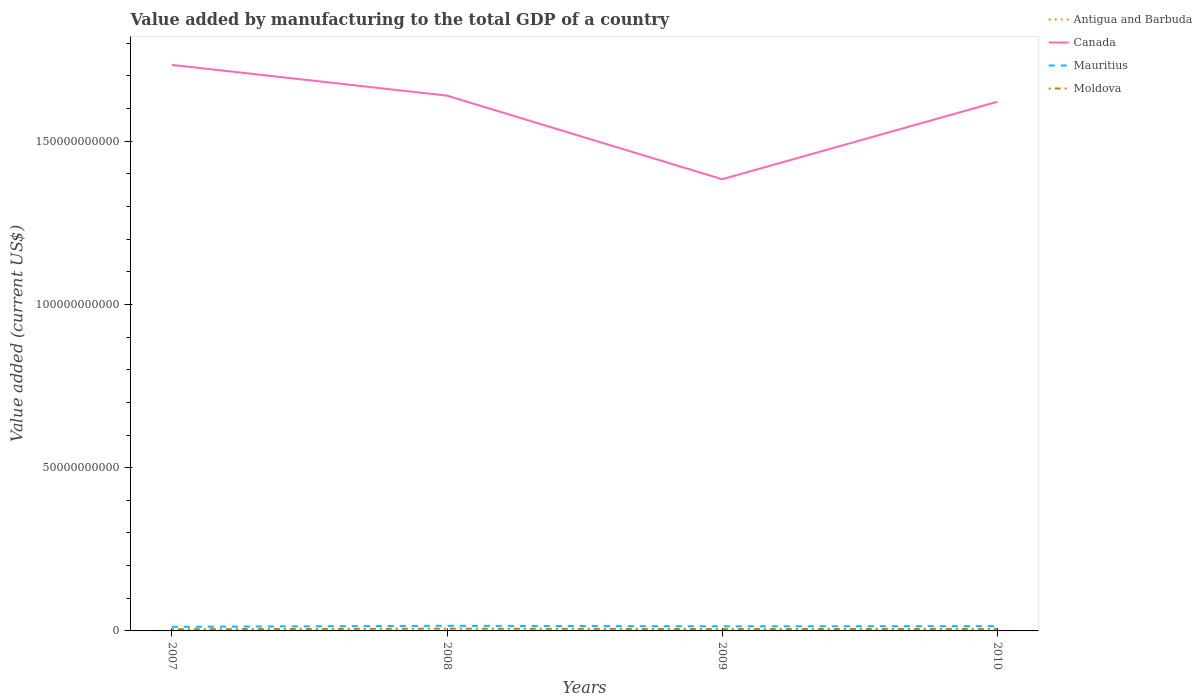Across all years, what is the maximum value added by manufacturing to the total GDP in Canada?
Offer a terse response. 1.38e+11. In which year was the value added by manufacturing to the total GDP in Canada maximum?
Keep it short and to the point. 2009. What is the total value added by manufacturing to the total GDP in Moldova in the graph?
Provide a short and direct response. -1.64e+08. What is the difference between the highest and the second highest value added by manufacturing to the total GDP in Moldova?
Offer a terse response. 1.64e+08. What is the difference between the highest and the lowest value added by manufacturing to the total GDP in Moldova?
Give a very brief answer. 2. How many lines are there?
Your response must be concise. 4. What is the difference between two consecutive major ticks on the Y-axis?
Provide a succinct answer. 5.00e+1. Does the graph contain any zero values?
Make the answer very short. No. Where does the legend appear in the graph?
Provide a short and direct response. Top right. What is the title of the graph?
Make the answer very short. Value added by manufacturing to the total GDP of a country. Does "Antigua and Barbuda" appear as one of the legend labels in the graph?
Your answer should be very brief. Yes. What is the label or title of the X-axis?
Your answer should be compact. Years. What is the label or title of the Y-axis?
Ensure brevity in your answer.  Value added (current US$). What is the Value added (current US$) of Antigua and Barbuda in 2007?
Give a very brief answer. 2.22e+07. What is the Value added (current US$) of Canada in 2007?
Your answer should be compact. 1.73e+11. What is the Value added (current US$) of Mauritius in 2007?
Offer a terse response. 1.26e+09. What is the Value added (current US$) in Moldova in 2007?
Make the answer very short. 5.19e+08. What is the Value added (current US$) of Antigua and Barbuda in 2008?
Provide a succinct answer. 2.18e+07. What is the Value added (current US$) of Canada in 2008?
Keep it short and to the point. 1.64e+11. What is the Value added (current US$) in Mauritius in 2008?
Your response must be concise. 1.58e+09. What is the Value added (current US$) of Moldova in 2008?
Offer a very short reply. 6.83e+08. What is the Value added (current US$) in Antigua and Barbuda in 2009?
Offer a terse response. 2.53e+07. What is the Value added (current US$) of Canada in 2009?
Provide a succinct answer. 1.38e+11. What is the Value added (current US$) of Mauritius in 2009?
Ensure brevity in your answer.  1.41e+09. What is the Value added (current US$) of Moldova in 2009?
Ensure brevity in your answer.  5.75e+08. What is the Value added (current US$) in Antigua and Barbuda in 2010?
Keep it short and to the point. 2.48e+07. What is the Value added (current US$) of Canada in 2010?
Offer a terse response. 1.62e+11. What is the Value added (current US$) in Mauritius in 2010?
Your answer should be very brief. 1.47e+09. What is the Value added (current US$) in Moldova in 2010?
Your answer should be very brief. 6.16e+08. Across all years, what is the maximum Value added (current US$) in Antigua and Barbuda?
Your response must be concise. 2.53e+07. Across all years, what is the maximum Value added (current US$) of Canada?
Offer a very short reply. 1.73e+11. Across all years, what is the maximum Value added (current US$) of Mauritius?
Offer a terse response. 1.58e+09. Across all years, what is the maximum Value added (current US$) of Moldova?
Your answer should be very brief. 6.83e+08. Across all years, what is the minimum Value added (current US$) of Antigua and Barbuda?
Offer a terse response. 2.18e+07. Across all years, what is the minimum Value added (current US$) in Canada?
Offer a terse response. 1.38e+11. Across all years, what is the minimum Value added (current US$) in Mauritius?
Ensure brevity in your answer.  1.26e+09. Across all years, what is the minimum Value added (current US$) in Moldova?
Ensure brevity in your answer.  5.19e+08. What is the total Value added (current US$) of Antigua and Barbuda in the graph?
Give a very brief answer. 9.41e+07. What is the total Value added (current US$) in Canada in the graph?
Provide a succinct answer. 6.38e+11. What is the total Value added (current US$) in Mauritius in the graph?
Make the answer very short. 5.71e+09. What is the total Value added (current US$) in Moldova in the graph?
Provide a short and direct response. 2.39e+09. What is the difference between the Value added (current US$) of Antigua and Barbuda in 2007 and that in 2008?
Provide a short and direct response. 4.83e+05. What is the difference between the Value added (current US$) of Canada in 2007 and that in 2008?
Ensure brevity in your answer.  9.42e+09. What is the difference between the Value added (current US$) in Mauritius in 2007 and that in 2008?
Ensure brevity in your answer.  -3.15e+08. What is the difference between the Value added (current US$) of Moldova in 2007 and that in 2008?
Your answer should be very brief. -1.64e+08. What is the difference between the Value added (current US$) of Antigua and Barbuda in 2007 and that in 2009?
Offer a terse response. -3.07e+06. What is the difference between the Value added (current US$) of Canada in 2007 and that in 2009?
Offer a very short reply. 3.50e+1. What is the difference between the Value added (current US$) of Mauritius in 2007 and that in 2009?
Provide a short and direct response. -1.45e+08. What is the difference between the Value added (current US$) of Moldova in 2007 and that in 2009?
Ensure brevity in your answer.  -5.63e+07. What is the difference between the Value added (current US$) in Antigua and Barbuda in 2007 and that in 2010?
Offer a terse response. -2.53e+06. What is the difference between the Value added (current US$) in Canada in 2007 and that in 2010?
Give a very brief answer. 1.13e+1. What is the difference between the Value added (current US$) in Mauritius in 2007 and that in 2010?
Provide a short and direct response. -2.07e+08. What is the difference between the Value added (current US$) of Moldova in 2007 and that in 2010?
Your answer should be very brief. -9.70e+07. What is the difference between the Value added (current US$) in Antigua and Barbuda in 2008 and that in 2009?
Ensure brevity in your answer.  -3.56e+06. What is the difference between the Value added (current US$) of Canada in 2008 and that in 2009?
Your answer should be very brief. 2.56e+1. What is the difference between the Value added (current US$) in Mauritius in 2008 and that in 2009?
Your response must be concise. 1.70e+08. What is the difference between the Value added (current US$) of Moldova in 2008 and that in 2009?
Your answer should be very brief. 1.07e+08. What is the difference between the Value added (current US$) of Antigua and Barbuda in 2008 and that in 2010?
Ensure brevity in your answer.  -3.01e+06. What is the difference between the Value added (current US$) in Canada in 2008 and that in 2010?
Provide a succinct answer. 1.87e+09. What is the difference between the Value added (current US$) in Mauritius in 2008 and that in 2010?
Provide a succinct answer. 1.08e+08. What is the difference between the Value added (current US$) of Moldova in 2008 and that in 2010?
Provide a short and direct response. 6.67e+07. What is the difference between the Value added (current US$) of Antigua and Barbuda in 2009 and that in 2010?
Give a very brief answer. 5.49e+05. What is the difference between the Value added (current US$) of Canada in 2009 and that in 2010?
Provide a succinct answer. -2.37e+1. What is the difference between the Value added (current US$) of Mauritius in 2009 and that in 2010?
Keep it short and to the point. -6.25e+07. What is the difference between the Value added (current US$) in Moldova in 2009 and that in 2010?
Your answer should be very brief. -4.07e+07. What is the difference between the Value added (current US$) in Antigua and Barbuda in 2007 and the Value added (current US$) in Canada in 2008?
Your answer should be compact. -1.64e+11. What is the difference between the Value added (current US$) of Antigua and Barbuda in 2007 and the Value added (current US$) of Mauritius in 2008?
Your answer should be very brief. -1.55e+09. What is the difference between the Value added (current US$) in Antigua and Barbuda in 2007 and the Value added (current US$) in Moldova in 2008?
Offer a very short reply. -6.60e+08. What is the difference between the Value added (current US$) of Canada in 2007 and the Value added (current US$) of Mauritius in 2008?
Make the answer very short. 1.72e+11. What is the difference between the Value added (current US$) in Canada in 2007 and the Value added (current US$) in Moldova in 2008?
Make the answer very short. 1.73e+11. What is the difference between the Value added (current US$) of Mauritius in 2007 and the Value added (current US$) of Moldova in 2008?
Provide a short and direct response. 5.78e+08. What is the difference between the Value added (current US$) in Antigua and Barbuda in 2007 and the Value added (current US$) in Canada in 2009?
Give a very brief answer. -1.38e+11. What is the difference between the Value added (current US$) in Antigua and Barbuda in 2007 and the Value added (current US$) in Mauritius in 2009?
Your response must be concise. -1.38e+09. What is the difference between the Value added (current US$) in Antigua and Barbuda in 2007 and the Value added (current US$) in Moldova in 2009?
Your answer should be compact. -5.53e+08. What is the difference between the Value added (current US$) in Canada in 2007 and the Value added (current US$) in Mauritius in 2009?
Your answer should be very brief. 1.72e+11. What is the difference between the Value added (current US$) of Canada in 2007 and the Value added (current US$) of Moldova in 2009?
Provide a short and direct response. 1.73e+11. What is the difference between the Value added (current US$) in Mauritius in 2007 and the Value added (current US$) in Moldova in 2009?
Make the answer very short. 6.85e+08. What is the difference between the Value added (current US$) of Antigua and Barbuda in 2007 and the Value added (current US$) of Canada in 2010?
Provide a succinct answer. -1.62e+11. What is the difference between the Value added (current US$) in Antigua and Barbuda in 2007 and the Value added (current US$) in Mauritius in 2010?
Your response must be concise. -1.45e+09. What is the difference between the Value added (current US$) of Antigua and Barbuda in 2007 and the Value added (current US$) of Moldova in 2010?
Ensure brevity in your answer.  -5.94e+08. What is the difference between the Value added (current US$) in Canada in 2007 and the Value added (current US$) in Mauritius in 2010?
Your answer should be very brief. 1.72e+11. What is the difference between the Value added (current US$) in Canada in 2007 and the Value added (current US$) in Moldova in 2010?
Provide a succinct answer. 1.73e+11. What is the difference between the Value added (current US$) in Mauritius in 2007 and the Value added (current US$) in Moldova in 2010?
Your response must be concise. 6.44e+08. What is the difference between the Value added (current US$) of Antigua and Barbuda in 2008 and the Value added (current US$) of Canada in 2009?
Offer a terse response. -1.38e+11. What is the difference between the Value added (current US$) of Antigua and Barbuda in 2008 and the Value added (current US$) of Mauritius in 2009?
Your response must be concise. -1.38e+09. What is the difference between the Value added (current US$) of Antigua and Barbuda in 2008 and the Value added (current US$) of Moldova in 2009?
Provide a short and direct response. -5.53e+08. What is the difference between the Value added (current US$) of Canada in 2008 and the Value added (current US$) of Mauritius in 2009?
Offer a terse response. 1.63e+11. What is the difference between the Value added (current US$) of Canada in 2008 and the Value added (current US$) of Moldova in 2009?
Your answer should be very brief. 1.63e+11. What is the difference between the Value added (current US$) of Mauritius in 2008 and the Value added (current US$) of Moldova in 2009?
Offer a very short reply. 1.00e+09. What is the difference between the Value added (current US$) of Antigua and Barbuda in 2008 and the Value added (current US$) of Canada in 2010?
Give a very brief answer. -1.62e+11. What is the difference between the Value added (current US$) in Antigua and Barbuda in 2008 and the Value added (current US$) in Mauritius in 2010?
Ensure brevity in your answer.  -1.45e+09. What is the difference between the Value added (current US$) of Antigua and Barbuda in 2008 and the Value added (current US$) of Moldova in 2010?
Your answer should be compact. -5.94e+08. What is the difference between the Value added (current US$) of Canada in 2008 and the Value added (current US$) of Mauritius in 2010?
Offer a terse response. 1.62e+11. What is the difference between the Value added (current US$) in Canada in 2008 and the Value added (current US$) in Moldova in 2010?
Ensure brevity in your answer.  1.63e+11. What is the difference between the Value added (current US$) of Mauritius in 2008 and the Value added (current US$) of Moldova in 2010?
Make the answer very short. 9.59e+08. What is the difference between the Value added (current US$) in Antigua and Barbuda in 2009 and the Value added (current US$) in Canada in 2010?
Ensure brevity in your answer.  -1.62e+11. What is the difference between the Value added (current US$) in Antigua and Barbuda in 2009 and the Value added (current US$) in Mauritius in 2010?
Make the answer very short. -1.44e+09. What is the difference between the Value added (current US$) of Antigua and Barbuda in 2009 and the Value added (current US$) of Moldova in 2010?
Ensure brevity in your answer.  -5.91e+08. What is the difference between the Value added (current US$) of Canada in 2009 and the Value added (current US$) of Mauritius in 2010?
Your answer should be very brief. 1.37e+11. What is the difference between the Value added (current US$) of Canada in 2009 and the Value added (current US$) of Moldova in 2010?
Offer a very short reply. 1.38e+11. What is the difference between the Value added (current US$) in Mauritius in 2009 and the Value added (current US$) in Moldova in 2010?
Your response must be concise. 7.89e+08. What is the average Value added (current US$) in Antigua and Barbuda per year?
Offer a terse response. 2.35e+07. What is the average Value added (current US$) of Canada per year?
Your response must be concise. 1.59e+11. What is the average Value added (current US$) of Mauritius per year?
Offer a terse response. 1.43e+09. What is the average Value added (current US$) of Moldova per year?
Provide a short and direct response. 5.98e+08. In the year 2007, what is the difference between the Value added (current US$) in Antigua and Barbuda and Value added (current US$) in Canada?
Make the answer very short. -1.73e+11. In the year 2007, what is the difference between the Value added (current US$) in Antigua and Barbuda and Value added (current US$) in Mauritius?
Provide a short and direct response. -1.24e+09. In the year 2007, what is the difference between the Value added (current US$) in Antigua and Barbuda and Value added (current US$) in Moldova?
Your response must be concise. -4.97e+08. In the year 2007, what is the difference between the Value added (current US$) of Canada and Value added (current US$) of Mauritius?
Keep it short and to the point. 1.72e+11. In the year 2007, what is the difference between the Value added (current US$) of Canada and Value added (current US$) of Moldova?
Provide a succinct answer. 1.73e+11. In the year 2007, what is the difference between the Value added (current US$) in Mauritius and Value added (current US$) in Moldova?
Provide a succinct answer. 7.41e+08. In the year 2008, what is the difference between the Value added (current US$) of Antigua and Barbuda and Value added (current US$) of Canada?
Offer a very short reply. -1.64e+11. In the year 2008, what is the difference between the Value added (current US$) in Antigua and Barbuda and Value added (current US$) in Mauritius?
Offer a very short reply. -1.55e+09. In the year 2008, what is the difference between the Value added (current US$) in Antigua and Barbuda and Value added (current US$) in Moldova?
Keep it short and to the point. -6.61e+08. In the year 2008, what is the difference between the Value added (current US$) of Canada and Value added (current US$) of Mauritius?
Your answer should be compact. 1.62e+11. In the year 2008, what is the difference between the Value added (current US$) in Canada and Value added (current US$) in Moldova?
Provide a short and direct response. 1.63e+11. In the year 2008, what is the difference between the Value added (current US$) in Mauritius and Value added (current US$) in Moldova?
Provide a succinct answer. 8.92e+08. In the year 2009, what is the difference between the Value added (current US$) in Antigua and Barbuda and Value added (current US$) in Canada?
Keep it short and to the point. -1.38e+11. In the year 2009, what is the difference between the Value added (current US$) of Antigua and Barbuda and Value added (current US$) of Mauritius?
Give a very brief answer. -1.38e+09. In the year 2009, what is the difference between the Value added (current US$) of Antigua and Barbuda and Value added (current US$) of Moldova?
Offer a terse response. -5.50e+08. In the year 2009, what is the difference between the Value added (current US$) in Canada and Value added (current US$) in Mauritius?
Provide a succinct answer. 1.37e+11. In the year 2009, what is the difference between the Value added (current US$) of Canada and Value added (current US$) of Moldova?
Provide a short and direct response. 1.38e+11. In the year 2009, what is the difference between the Value added (current US$) in Mauritius and Value added (current US$) in Moldova?
Give a very brief answer. 8.30e+08. In the year 2010, what is the difference between the Value added (current US$) in Antigua and Barbuda and Value added (current US$) in Canada?
Offer a terse response. -1.62e+11. In the year 2010, what is the difference between the Value added (current US$) of Antigua and Barbuda and Value added (current US$) of Mauritius?
Make the answer very short. -1.44e+09. In the year 2010, what is the difference between the Value added (current US$) in Antigua and Barbuda and Value added (current US$) in Moldova?
Provide a short and direct response. -5.91e+08. In the year 2010, what is the difference between the Value added (current US$) of Canada and Value added (current US$) of Mauritius?
Make the answer very short. 1.61e+11. In the year 2010, what is the difference between the Value added (current US$) in Canada and Value added (current US$) in Moldova?
Provide a succinct answer. 1.61e+11. In the year 2010, what is the difference between the Value added (current US$) in Mauritius and Value added (current US$) in Moldova?
Ensure brevity in your answer.  8.52e+08. What is the ratio of the Value added (current US$) in Antigua and Barbuda in 2007 to that in 2008?
Provide a short and direct response. 1.02. What is the ratio of the Value added (current US$) in Canada in 2007 to that in 2008?
Ensure brevity in your answer.  1.06. What is the ratio of the Value added (current US$) of Mauritius in 2007 to that in 2008?
Your answer should be compact. 0.8. What is the ratio of the Value added (current US$) in Moldova in 2007 to that in 2008?
Your response must be concise. 0.76. What is the ratio of the Value added (current US$) of Antigua and Barbuda in 2007 to that in 2009?
Your response must be concise. 0.88. What is the ratio of the Value added (current US$) of Canada in 2007 to that in 2009?
Offer a terse response. 1.25. What is the ratio of the Value added (current US$) in Mauritius in 2007 to that in 2009?
Keep it short and to the point. 0.9. What is the ratio of the Value added (current US$) of Moldova in 2007 to that in 2009?
Provide a succinct answer. 0.9. What is the ratio of the Value added (current US$) in Antigua and Barbuda in 2007 to that in 2010?
Offer a terse response. 0.9. What is the ratio of the Value added (current US$) of Canada in 2007 to that in 2010?
Offer a terse response. 1.07. What is the ratio of the Value added (current US$) in Mauritius in 2007 to that in 2010?
Offer a terse response. 0.86. What is the ratio of the Value added (current US$) of Moldova in 2007 to that in 2010?
Keep it short and to the point. 0.84. What is the ratio of the Value added (current US$) in Antigua and Barbuda in 2008 to that in 2009?
Your answer should be compact. 0.86. What is the ratio of the Value added (current US$) in Canada in 2008 to that in 2009?
Give a very brief answer. 1.19. What is the ratio of the Value added (current US$) of Mauritius in 2008 to that in 2009?
Keep it short and to the point. 1.12. What is the ratio of the Value added (current US$) in Moldova in 2008 to that in 2009?
Keep it short and to the point. 1.19. What is the ratio of the Value added (current US$) of Antigua and Barbuda in 2008 to that in 2010?
Provide a short and direct response. 0.88. What is the ratio of the Value added (current US$) in Canada in 2008 to that in 2010?
Your answer should be compact. 1.01. What is the ratio of the Value added (current US$) of Mauritius in 2008 to that in 2010?
Your answer should be compact. 1.07. What is the ratio of the Value added (current US$) in Moldova in 2008 to that in 2010?
Keep it short and to the point. 1.11. What is the ratio of the Value added (current US$) in Antigua and Barbuda in 2009 to that in 2010?
Offer a terse response. 1.02. What is the ratio of the Value added (current US$) in Canada in 2009 to that in 2010?
Ensure brevity in your answer.  0.85. What is the ratio of the Value added (current US$) of Mauritius in 2009 to that in 2010?
Give a very brief answer. 0.96. What is the ratio of the Value added (current US$) of Moldova in 2009 to that in 2010?
Your answer should be very brief. 0.93. What is the difference between the highest and the second highest Value added (current US$) of Antigua and Barbuda?
Your answer should be compact. 5.49e+05. What is the difference between the highest and the second highest Value added (current US$) of Canada?
Ensure brevity in your answer.  9.42e+09. What is the difference between the highest and the second highest Value added (current US$) of Mauritius?
Ensure brevity in your answer.  1.08e+08. What is the difference between the highest and the second highest Value added (current US$) in Moldova?
Your answer should be very brief. 6.67e+07. What is the difference between the highest and the lowest Value added (current US$) of Antigua and Barbuda?
Offer a very short reply. 3.56e+06. What is the difference between the highest and the lowest Value added (current US$) of Canada?
Offer a very short reply. 3.50e+1. What is the difference between the highest and the lowest Value added (current US$) in Mauritius?
Keep it short and to the point. 3.15e+08. What is the difference between the highest and the lowest Value added (current US$) of Moldova?
Offer a terse response. 1.64e+08. 